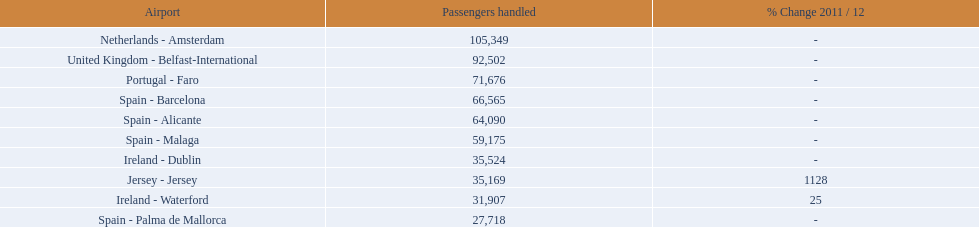What are the 10 busiest routes to and from london southend airport? Netherlands - Amsterdam, United Kingdom - Belfast-International, Portugal - Faro, Spain - Barcelona, Spain - Alicante, Spain - Malaga, Ireland - Dublin, Jersey - Jersey, Ireland - Waterford, Spain - Palma de Mallorca. Of these, which airport is in portugal? Portugal - Faro. 